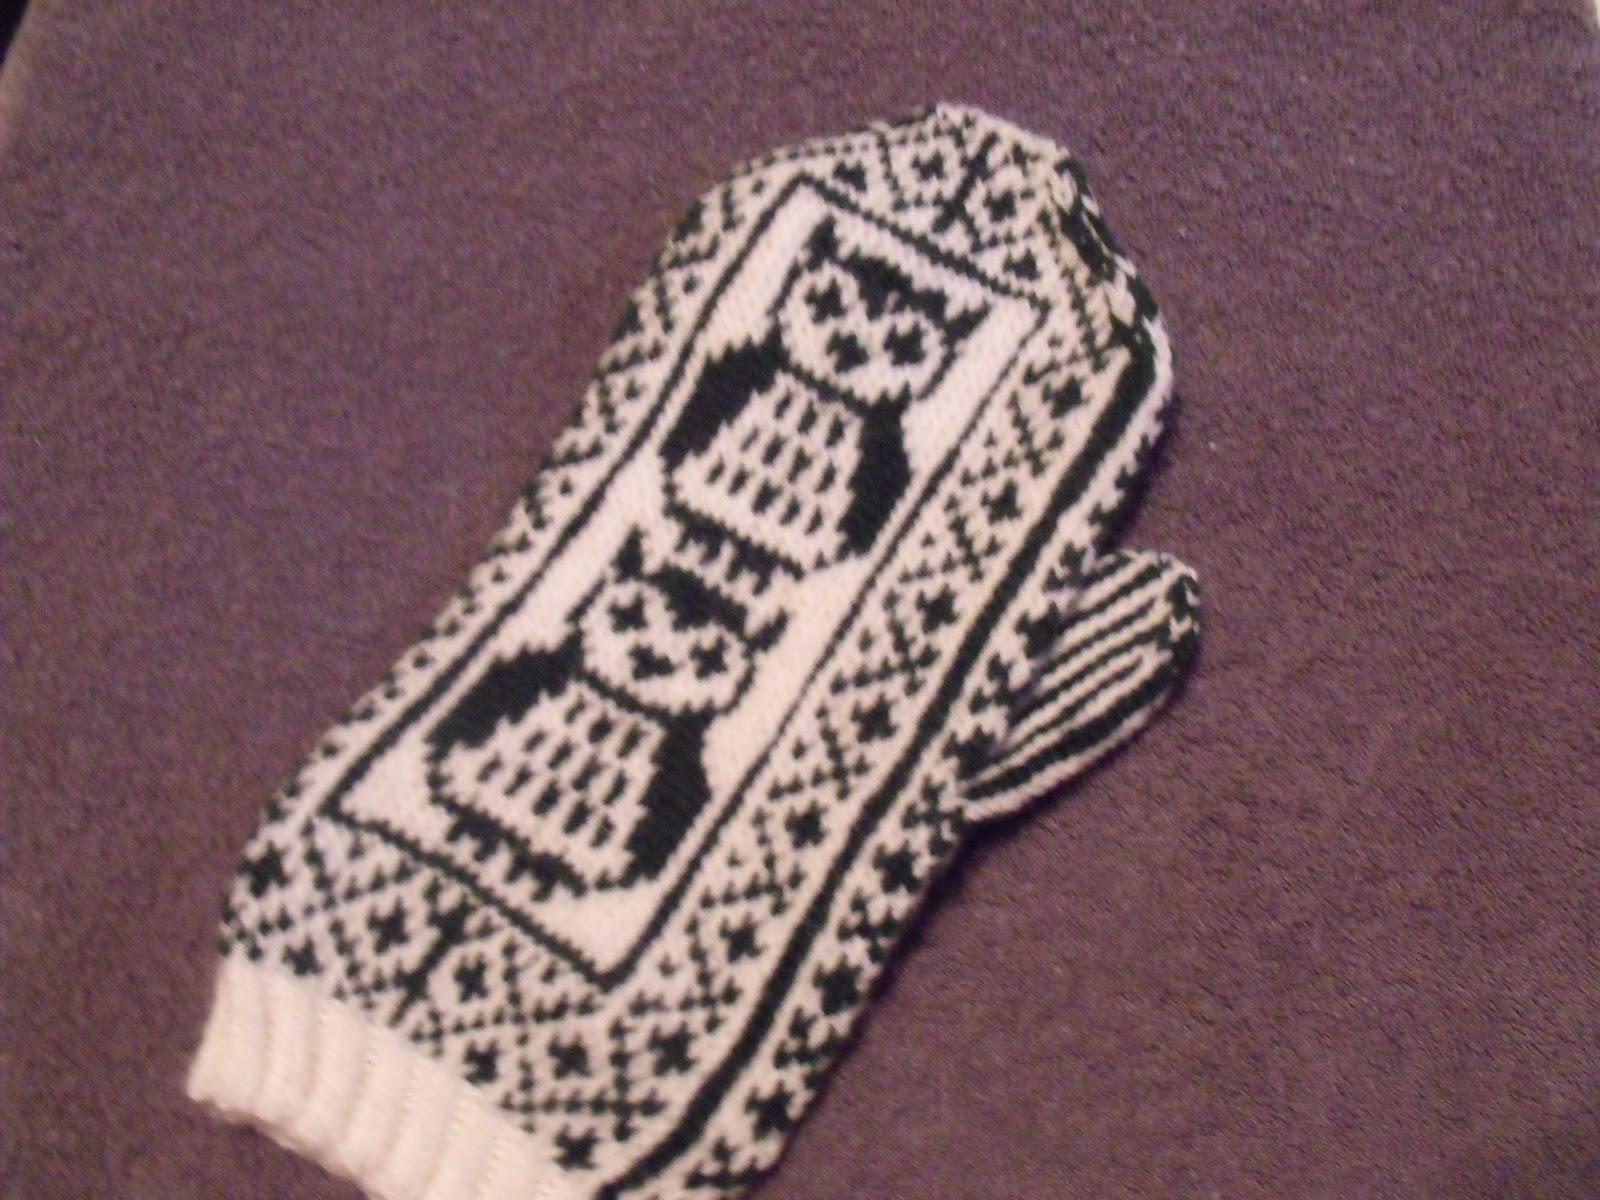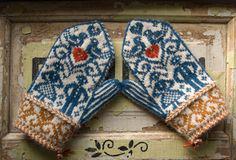The first image is the image on the left, the second image is the image on the right. Analyze the images presented: Is the assertion "There is at least one human hand in the image on the right." valid? Answer yes or no. No. 